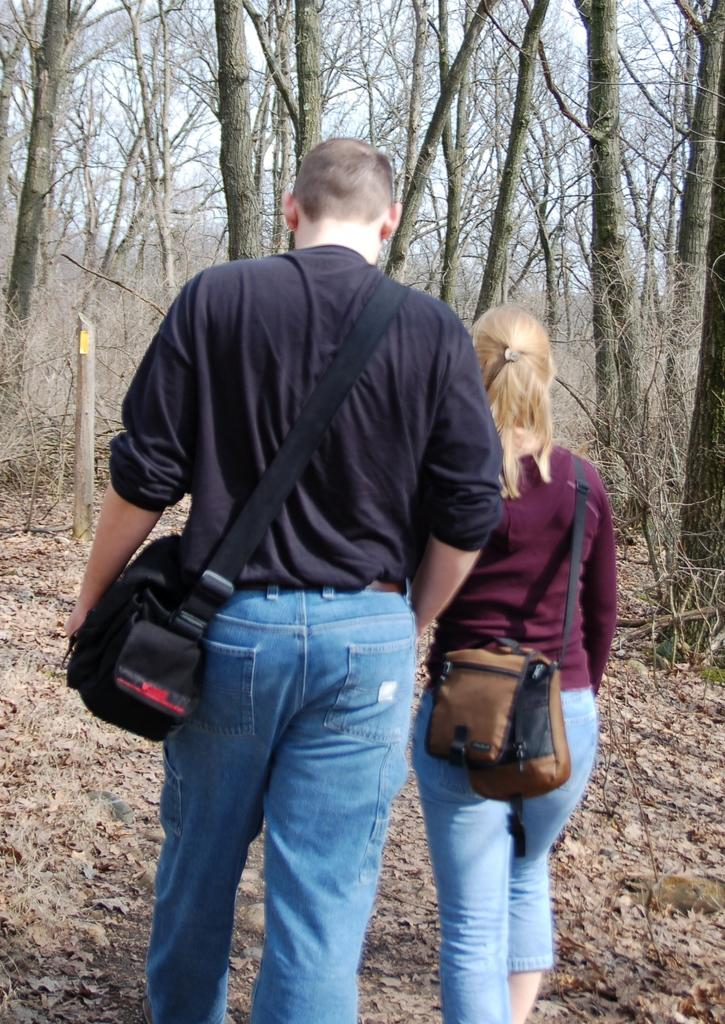What is the setting of the image? The image is taken in a forest. What are the two people in the image doing? The two people are walking in the center of the image. What are the people carrying on their backs? The people are wearing bags. What can be seen in the background of the image? There are trees in the background of the image. What type of marble can be seen on the ground in the image? There is no marble present in the image; it is taken in a forest with trees and people walking. How does the feather move around in the image? There is no feather present in the image; it features two people walking in a forest. 